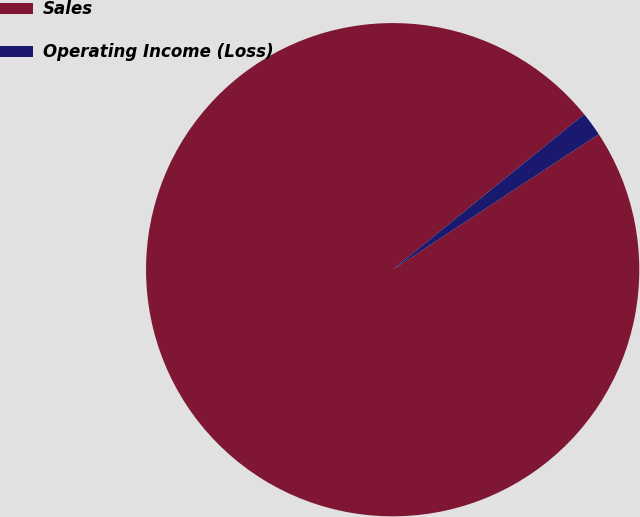<chart> <loc_0><loc_0><loc_500><loc_500><pie_chart><fcel>Sales<fcel>Operating Income (Loss)<nl><fcel>98.4%<fcel>1.6%<nl></chart> 